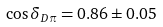Convert formula to latex. <formula><loc_0><loc_0><loc_500><loc_500>\cos \delta _ { D \pi } = 0 . 8 6 \pm 0 . 0 5</formula> 